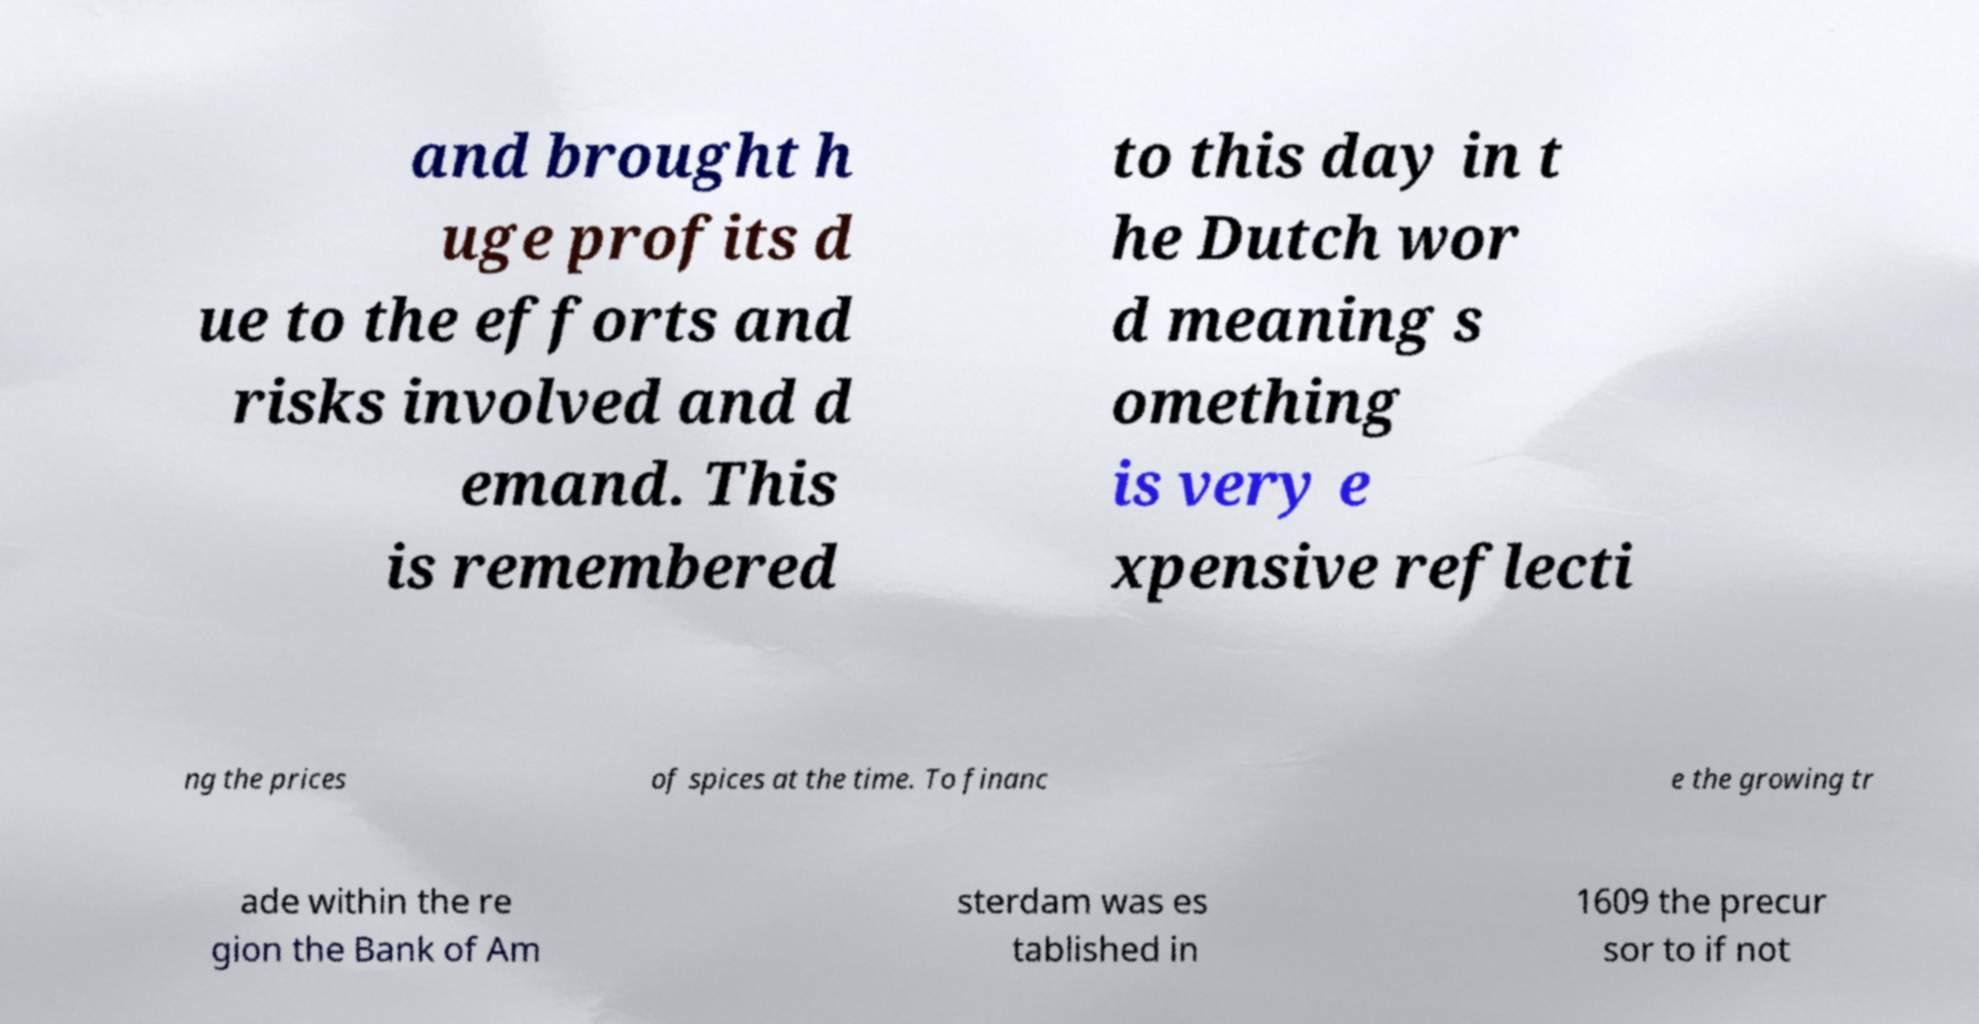Can you read and provide the text displayed in the image?This photo seems to have some interesting text. Can you extract and type it out for me? and brought h uge profits d ue to the efforts and risks involved and d emand. This is remembered to this day in t he Dutch wor d meaning s omething is very e xpensive reflecti ng the prices of spices at the time. To financ e the growing tr ade within the re gion the Bank of Am sterdam was es tablished in 1609 the precur sor to if not 